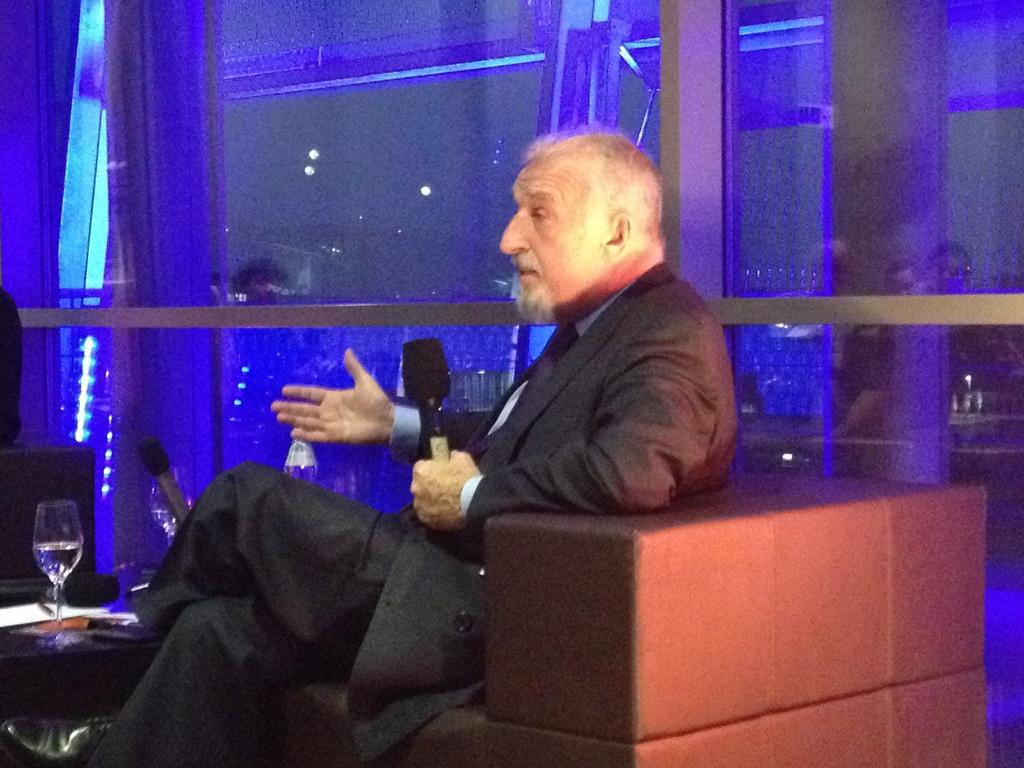Who is present in the image? There is a man in the image. What is the man doing in the image? The man is sitting on a sofa and holding a microphone. What else can be seen in the image? There is a table in the image. What is on the table? There is a glass on the table. What type of fact can be seen on the man's sock in the image? There is no sock visible in the image, and therefore no fact can be seen on it. 